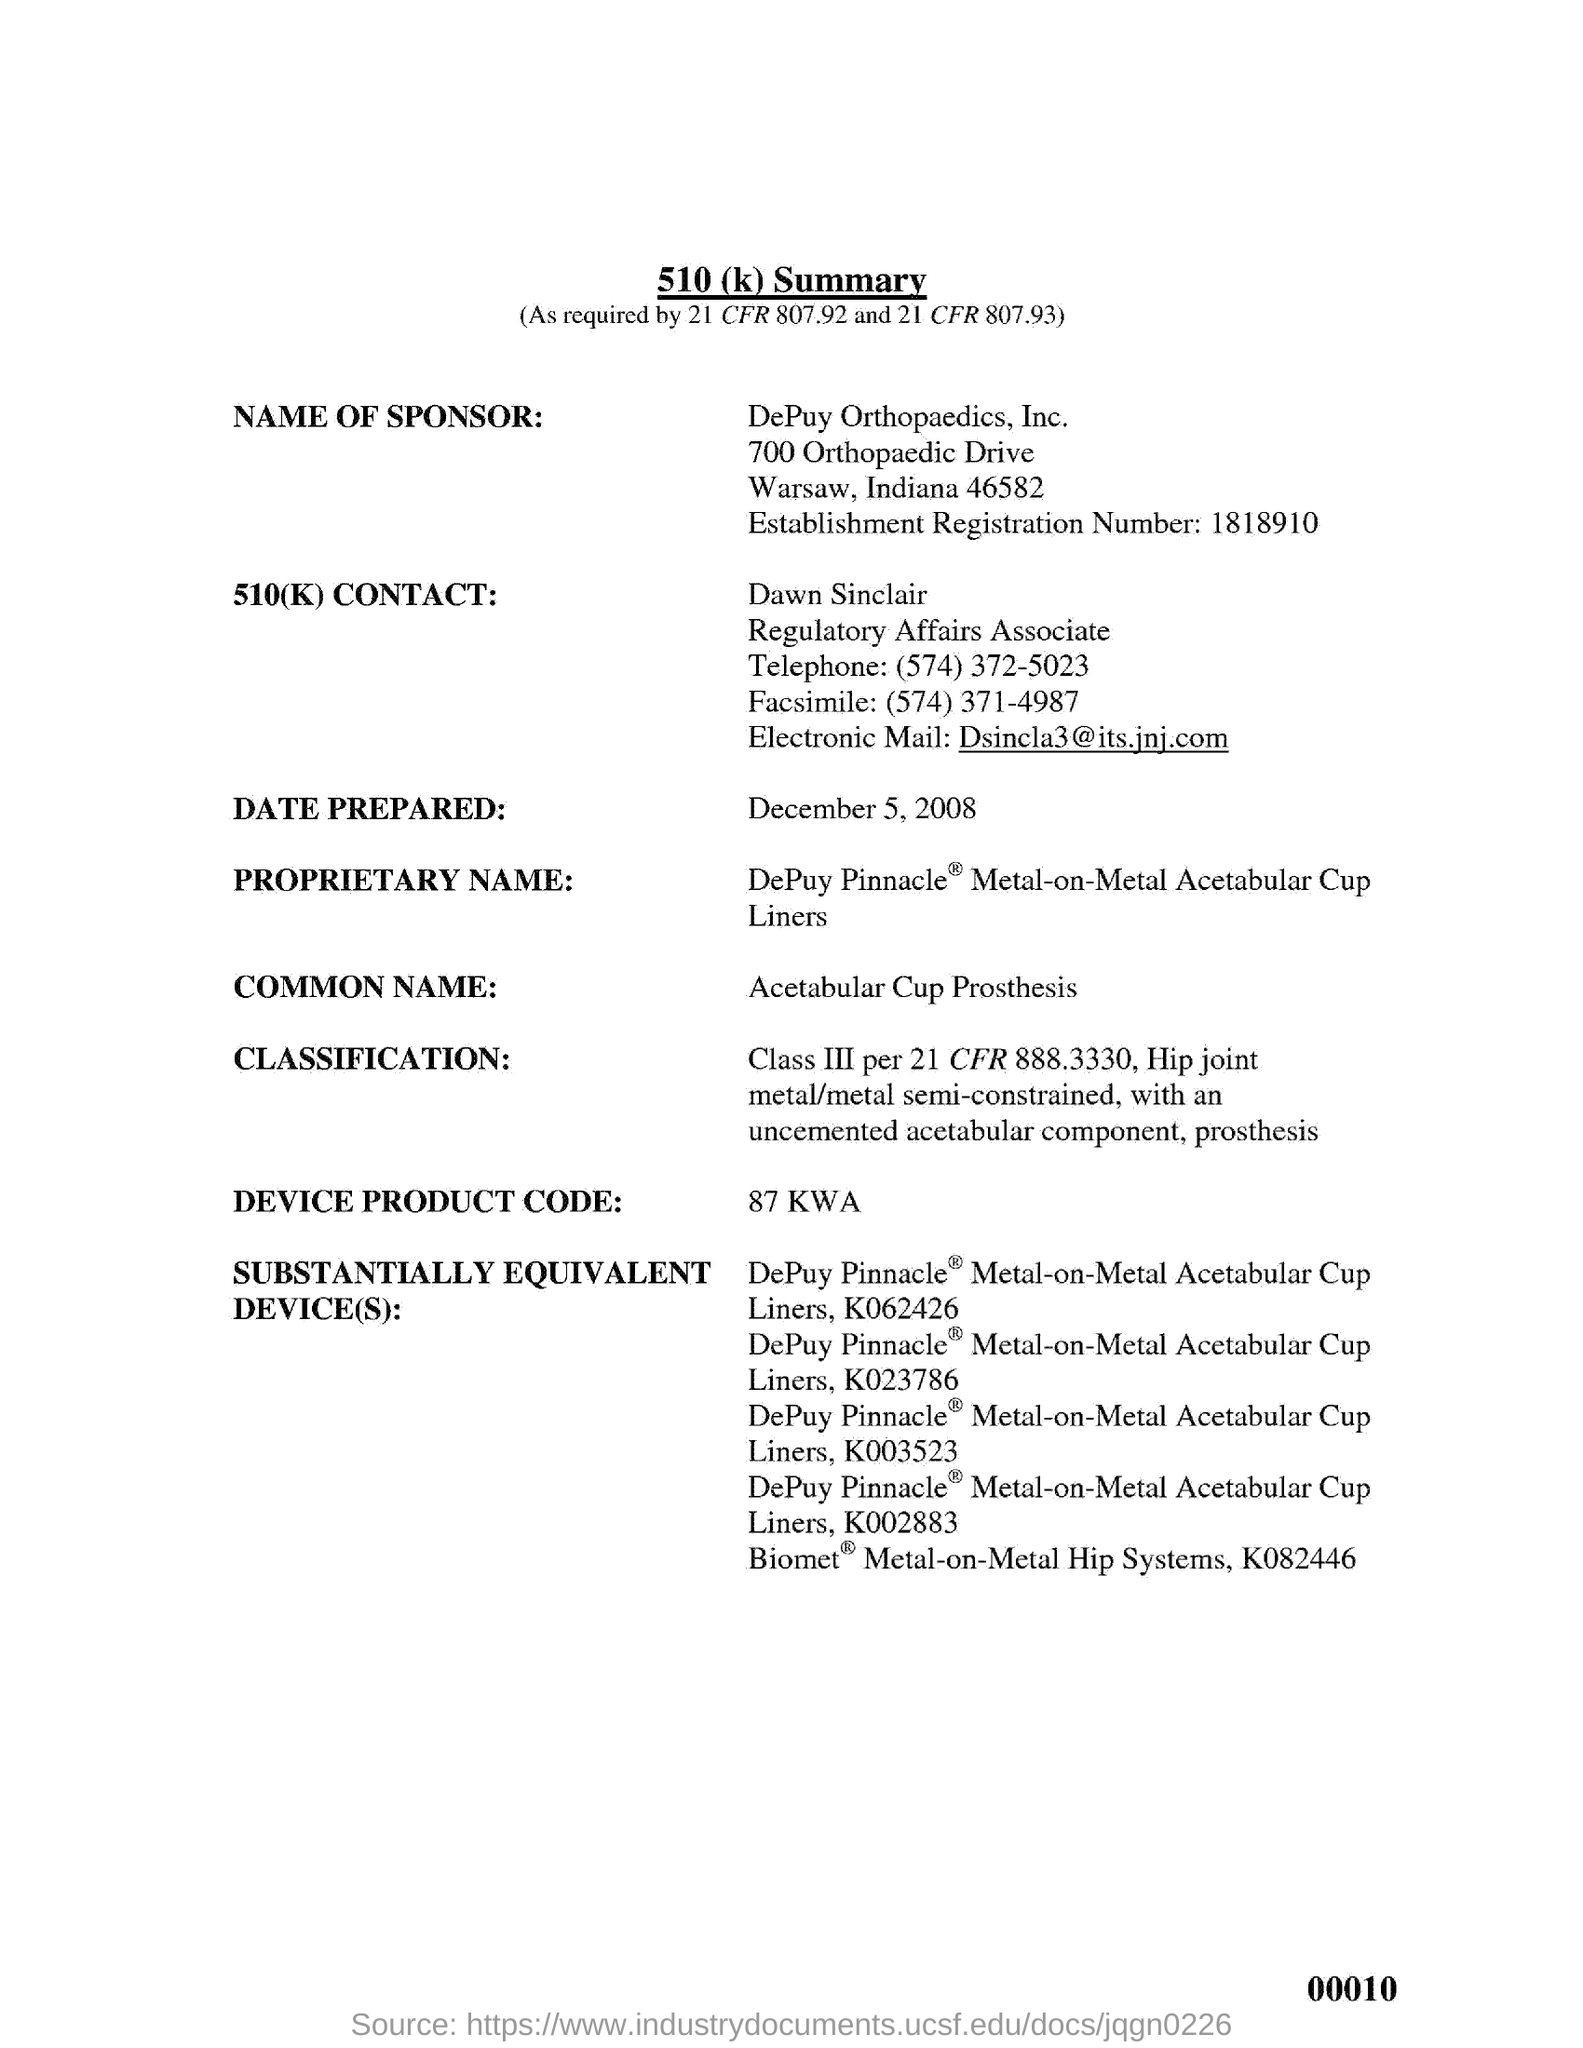What is the name of sponsor?
Make the answer very short. DePuy Orthopaedics, Inc. What is the name of 510(k) CONTACT?
Provide a succinct answer. Dawn Sinclair. What is the COMMON NAME?
Offer a very short reply. Acetabular Cup Prosthesis. What is the DEVICE PRODUCT CODE?
Offer a very short reply. 87 KWA. What is "DATE PREPARED" mentioned under 510 (k) Summary?
Offer a terse response. December 5, 2008. What is  "Facsimile" of 510(k) CONTACT?
Your answer should be very brief. (574) 371-4987. What is the designation of "Dawn Sinclair"?
Ensure brevity in your answer.  Regulatory Affairs Associate. What is the "Telephone" number of "Dawn Sinclair"?
Make the answer very short. (574) 372-5023. 